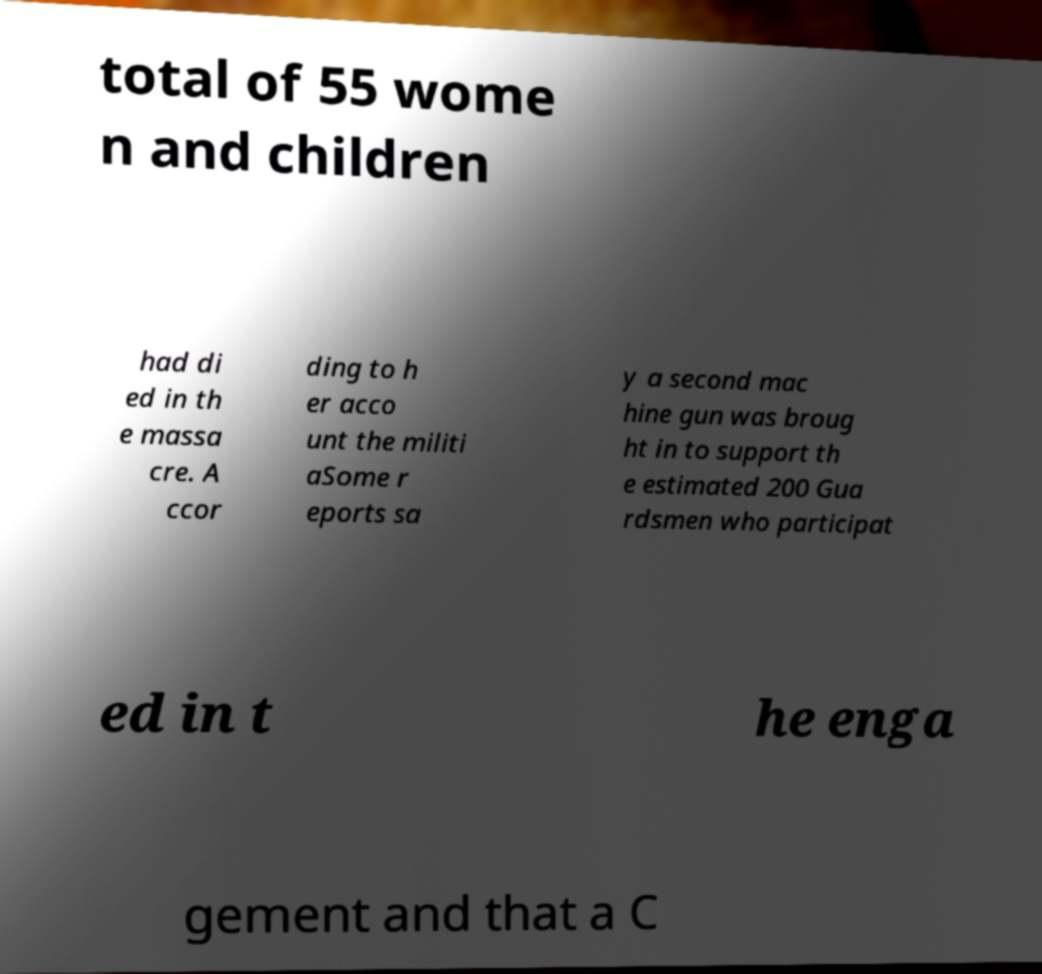Can you accurately transcribe the text from the provided image for me? total of 55 wome n and children had di ed in th e massa cre. A ccor ding to h er acco unt the militi aSome r eports sa y a second mac hine gun was broug ht in to support th e estimated 200 Gua rdsmen who participat ed in t he enga gement and that a C 